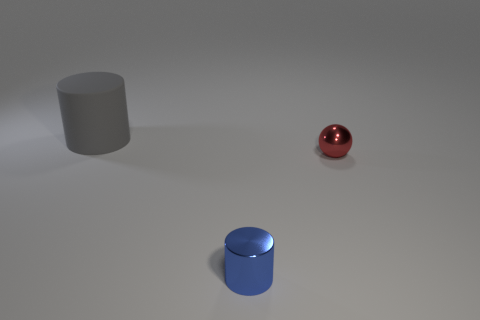Is there any other thing that is the same size as the gray cylinder?
Your answer should be very brief. No. Are there any other things that have the same material as the tiny red ball?
Keep it short and to the point. Yes. Is there a large matte block that has the same color as the tiny metallic cylinder?
Your answer should be very brief. No. Is there a big red thing that has the same material as the small red ball?
Offer a very short reply. No. There is a object that is to the left of the small red metal thing and in front of the rubber thing; what shape is it?
Your response must be concise. Cylinder. How many large things are either brown matte things or gray cylinders?
Ensure brevity in your answer.  1. What is the material of the small blue cylinder?
Your response must be concise. Metal. How many other things are the same shape as the matte thing?
Offer a very short reply. 1. What size is the blue metallic object?
Your response must be concise. Small. There is a object that is behind the blue object and on the right side of the gray thing; what size is it?
Ensure brevity in your answer.  Small. 